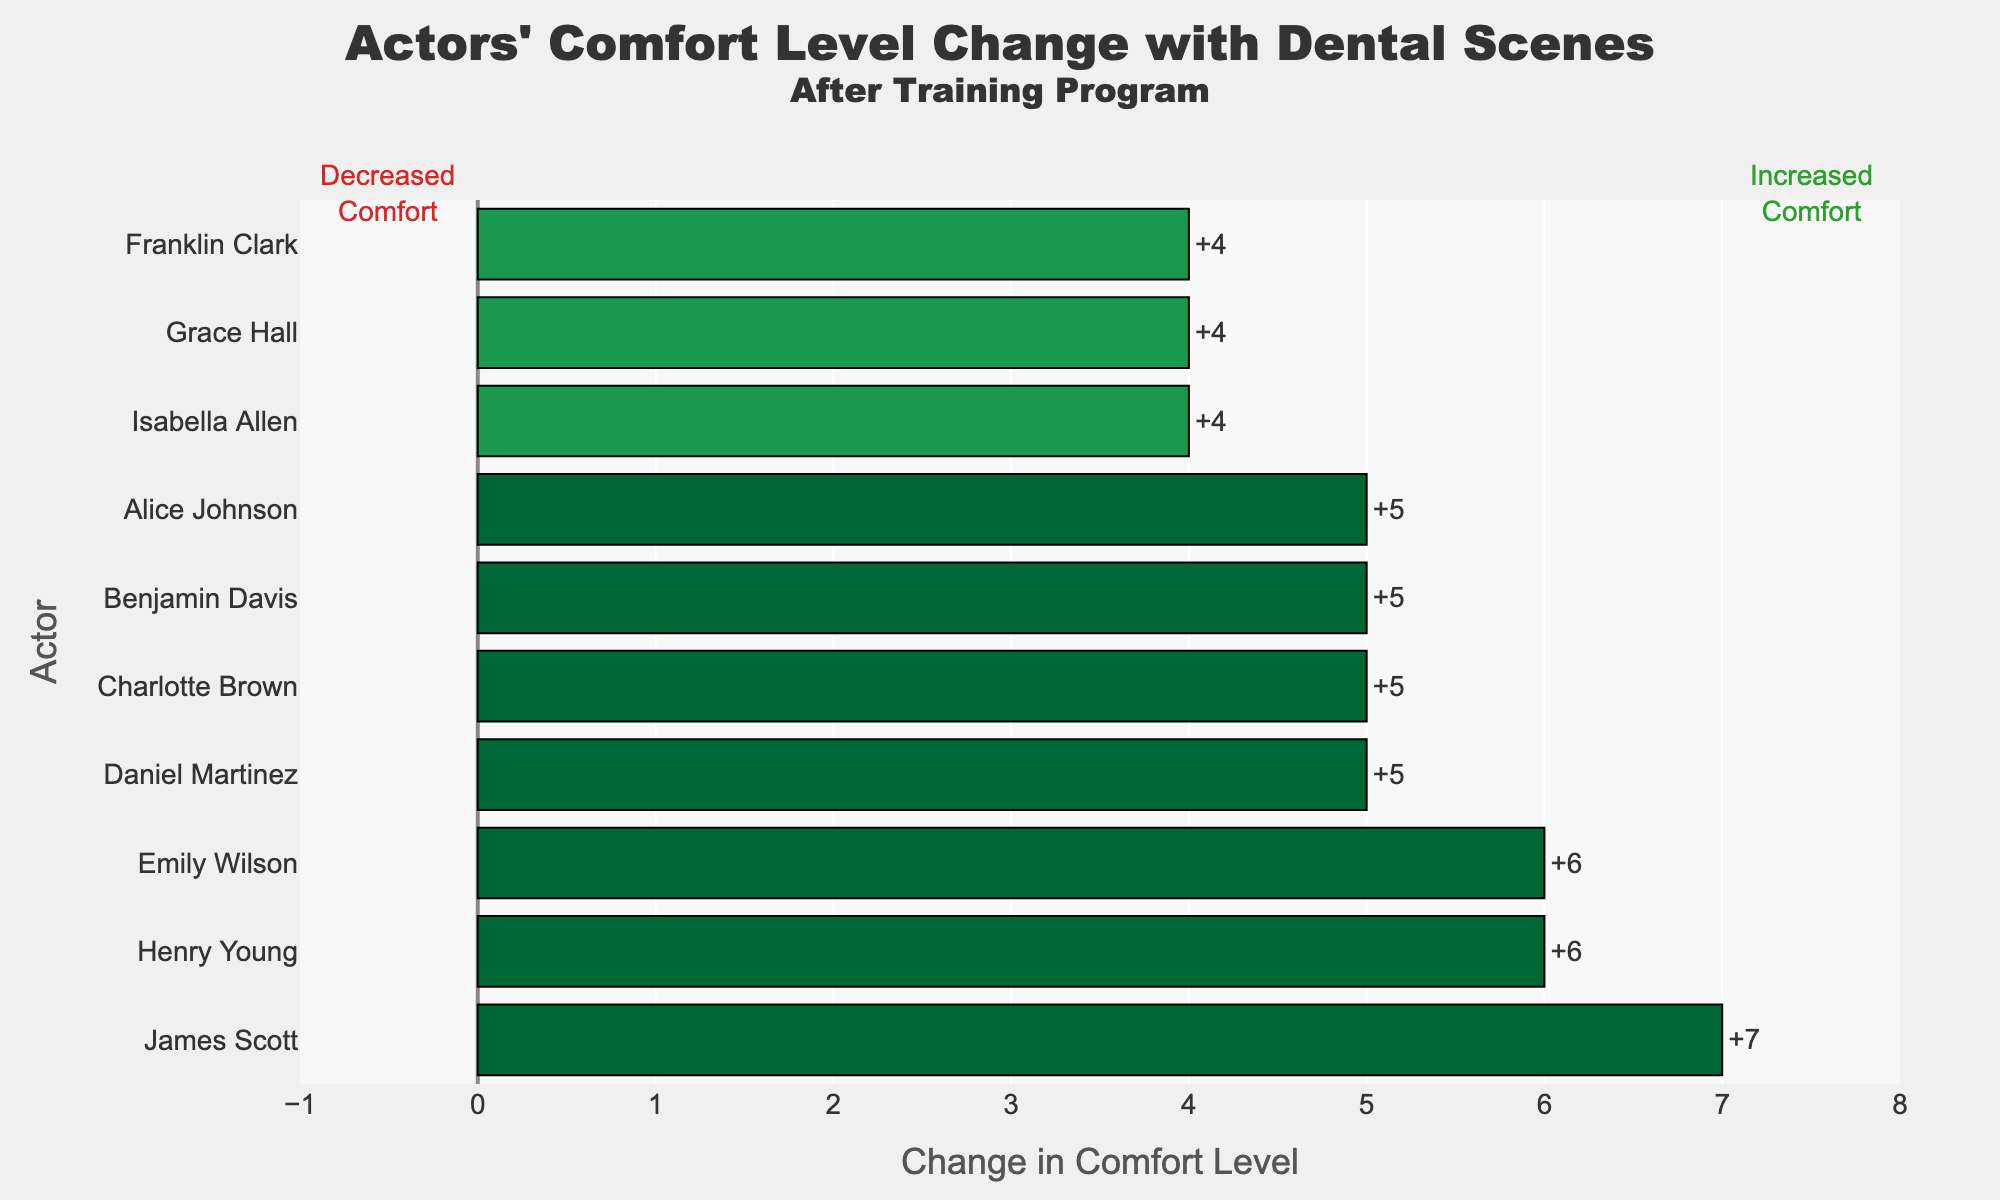Which actor had the highest increase in comfort level with dental scenes after the training? By inspecting the length of the bars, Daniel Martinez shows the highest positive change of +5.
Answer: Daniel Martinez Which actor had the lowest comfort level with dental scenes before the training? By examining the data, Charlotte Brown and Grace Hall both had a comfort level of 1 before the training. However, in a diverging bar chart, if they are ordered by the change, Charlotte Brown would be listed first with a lower before comfort level.
Answer: Charlotte Brown What's the average increase in comfort level after the training? By summing up all the changes in comfort level: (5 + 5 + 5 + 5 + 6 + 4 + 4 + 6 + 4 + 7 = 51), and dividing by the total number of actors (10), we get the average change as 51/10.
Answer: 5.1 How many actors experienced an increase in their comfort level by 6 points or more? By visually inspecting the bars, three actors have a change of 6: Emily Wilson, Henry Young, and James Scott.
Answer: 3 Which actor had the smallest increase in comfort level with dental scenes after the training? By checking the shortest positive bars, Grace Hall shows the smallest increase of +4.
Answer: Grace Hall How much higher is Benjamin Davis’s comfort level after training compared to Grace Hall? Calculate the difference in comfort levels after training: Benjamin Davis increased by 5 points and Grace Hall by 4 points. Thus, Benjamin's comfort level increased 1 point more than Grace’s.
Answer: 1 point What is the combined increase in the comfort levels of Alice Johnson and Franklin Clark? Alice Johnson's comfort level increased by 5, and Franklin Clark’s by 4. Their combined increase is 5 + 4 = 9.
Answer: 9 Which actor's comfort level increased to an 8 after the training? By looking at the maximum comfort levels reached after training, actors reaching an 8 level include: Benjamin Davis, Emily Wilson, and Henry Young.
Answer: Benjamin Davis, Emily Wilson, Henry Young Which actors started with a comfort level of 2 before the training? By noting the initial comfort levels across the dataset, actors starting at 2 are Alice Johnson, Emily Wilson, Henry Young, and James Scott.
Answer: Alice Johnson, Emily Wilson, Henry Young, James Scott 